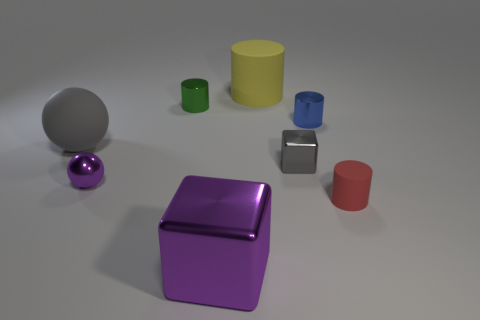There is a tiny shiny thing that is to the left of the small metallic cylinder on the left side of the shiny block to the right of the large yellow cylinder; what is its color?
Offer a very short reply. Purple. Are there the same number of tiny rubber cylinders that are behind the large gray matte ball and tiny cylinders in front of the blue metal cylinder?
Offer a terse response. No. What is the shape of the gray shiny object that is the same size as the red rubber thing?
Make the answer very short. Cube. Is there a shiny object of the same color as the large metallic cube?
Ensure brevity in your answer.  Yes. There is a purple thing behind the red object; what is its shape?
Provide a succinct answer. Sphere. What color is the matte sphere?
Offer a terse response. Gray. What color is the other tiny cube that is the same material as the purple block?
Your answer should be very brief. Gray. What number of things are made of the same material as the small red cylinder?
Make the answer very short. 2. What number of big things are behind the small matte thing?
Your response must be concise. 2. Is the big thing that is behind the matte sphere made of the same material as the big thing on the left side of the purple metallic block?
Offer a very short reply. Yes. 